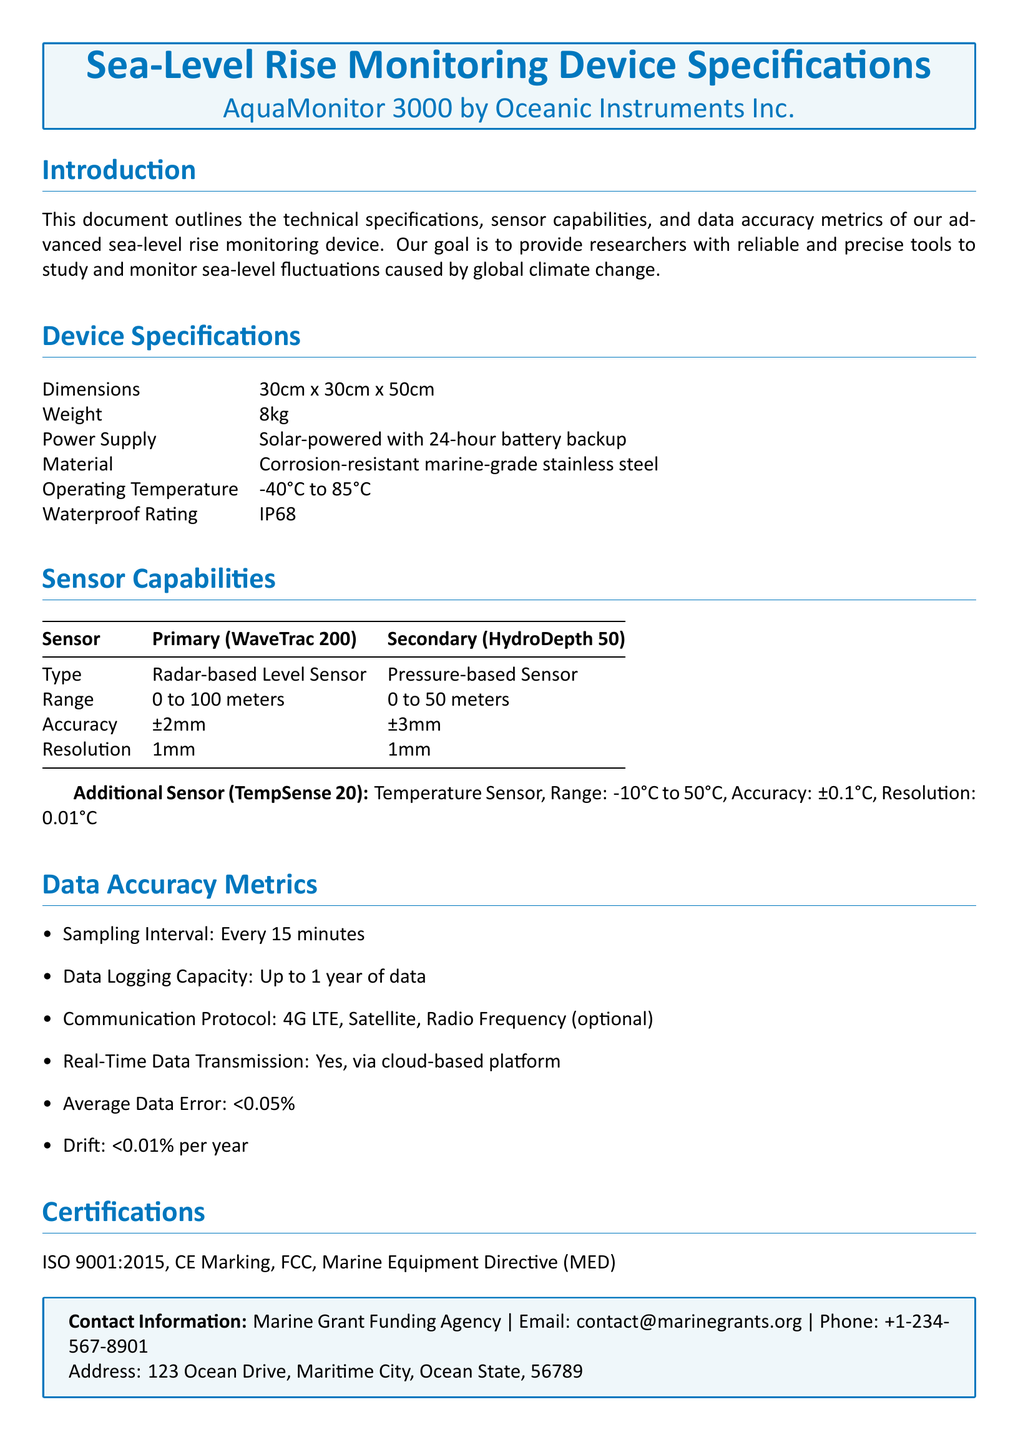What is the power supply type? The power supply type is indicated in the specifications, which states it is solar-powered with a 24-hour battery backup.
Answer: Solar-powered with 24-hour battery backup What is the weight of the device? The weight of the device is provided under device specifications.
Answer: 8kg What is the accuracy of the primary sensor? The accuracy for the primary sensor (WaveTrac 200) can be found in the sensor capabilities section.
Answer: ±2mm What is the resolution of the secondary sensor? The resolution of the secondary sensor (HydroDepth 50) is detailed in the sensor capabilities table.
Answer: 1mm How often does the device log data? The data logging frequency is mentioned in the data accuracy metrics section of the document.
Answer: Every 15 minutes What is the waterproof rating of the device? The waterproof rating is specified in the device specifications section.
Answer: IP68 What are the certifications listed for the device? The certifications can be found in the designated section of the document.
Answer: ISO 9001:2015, CE Marking, FCC, Marine Equipment Directive (MED) What is the temperature range of the additional sensor? The temperature range for the additional sensor (TempSense 20) is provided in the sensor capabilities section.
Answer: -10°C to 50°C What is the data logging capacity? The data logging capacity is mentioned in the data accuracy metrics section.
Answer: Up to 1 year of data 